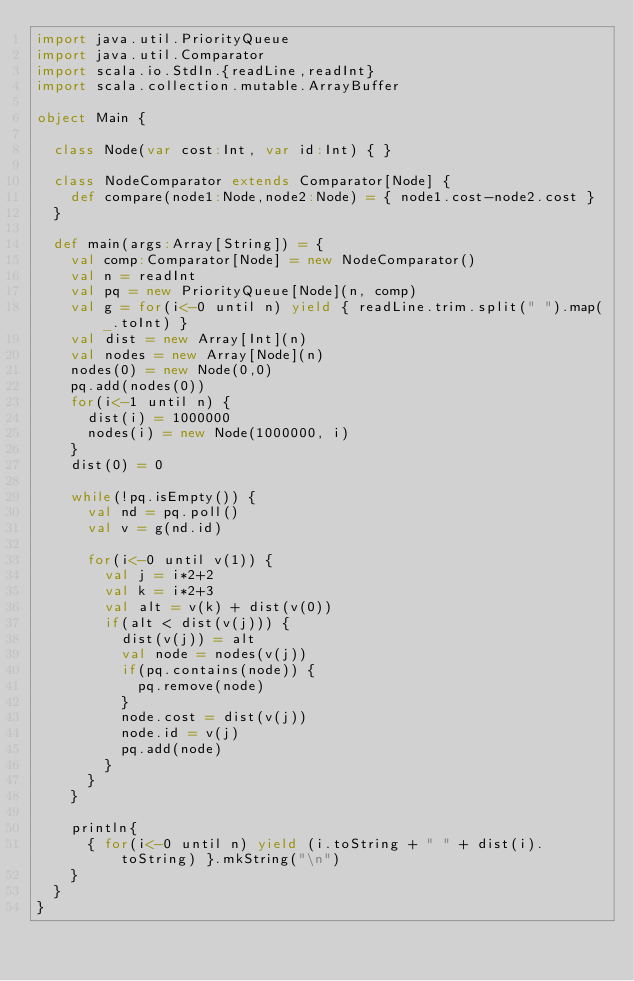<code> <loc_0><loc_0><loc_500><loc_500><_Scala_>import java.util.PriorityQueue
import java.util.Comparator
import scala.io.StdIn.{readLine,readInt}
import scala.collection.mutable.ArrayBuffer

object Main {

  class Node(var cost:Int, var id:Int) { }

  class NodeComparator extends Comparator[Node] {
    def compare(node1:Node,node2:Node) = { node1.cost-node2.cost }
  }

  def main(args:Array[String]) = {
    val comp:Comparator[Node] = new NodeComparator()
    val n = readInt
    val pq = new PriorityQueue[Node](n, comp)
    val g = for(i<-0 until n) yield { readLine.trim.split(" ").map(_.toInt) }
    val dist = new Array[Int](n)
    val nodes = new Array[Node](n)
    nodes(0) = new Node(0,0)
    pq.add(nodes(0))
    for(i<-1 until n) {
      dist(i) = 1000000
      nodes(i) = new Node(1000000, i)
    }
    dist(0) = 0

    while(!pq.isEmpty()) {
      val nd = pq.poll()
      val v = g(nd.id)

      for(i<-0 until v(1)) {
        val j = i*2+2
        val k = i*2+3
        val alt = v(k) + dist(v(0))
        if(alt < dist(v(j))) {
          dist(v(j)) = alt
          val node = nodes(v(j))
          if(pq.contains(node)) {
            pq.remove(node)
          }
          node.cost = dist(v(j))
          node.id = v(j)
          pq.add(node)
        }
      }
    }

    println{
      { for(i<-0 until n) yield (i.toString + " " + dist(i).toString) }.mkString("\n")
    }
  }
}</code> 